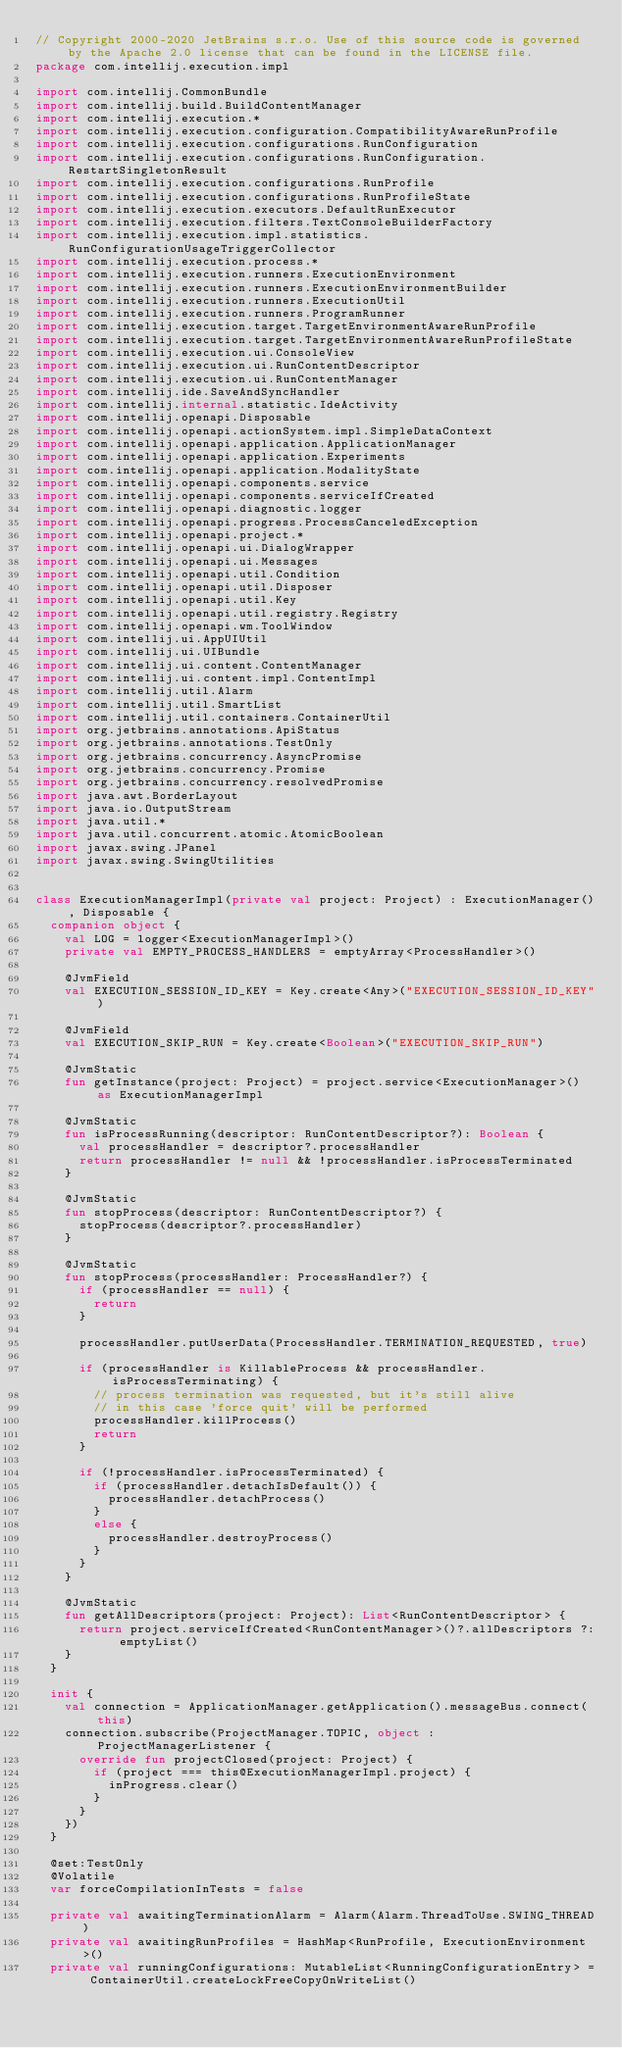<code> <loc_0><loc_0><loc_500><loc_500><_Kotlin_>// Copyright 2000-2020 JetBrains s.r.o. Use of this source code is governed by the Apache 2.0 license that can be found in the LICENSE file.
package com.intellij.execution.impl

import com.intellij.CommonBundle
import com.intellij.build.BuildContentManager
import com.intellij.execution.*
import com.intellij.execution.configuration.CompatibilityAwareRunProfile
import com.intellij.execution.configurations.RunConfiguration
import com.intellij.execution.configurations.RunConfiguration.RestartSingletonResult
import com.intellij.execution.configurations.RunProfile
import com.intellij.execution.configurations.RunProfileState
import com.intellij.execution.executors.DefaultRunExecutor
import com.intellij.execution.filters.TextConsoleBuilderFactory
import com.intellij.execution.impl.statistics.RunConfigurationUsageTriggerCollector
import com.intellij.execution.process.*
import com.intellij.execution.runners.ExecutionEnvironment
import com.intellij.execution.runners.ExecutionEnvironmentBuilder
import com.intellij.execution.runners.ExecutionUtil
import com.intellij.execution.runners.ProgramRunner
import com.intellij.execution.target.TargetEnvironmentAwareRunProfile
import com.intellij.execution.target.TargetEnvironmentAwareRunProfileState
import com.intellij.execution.ui.ConsoleView
import com.intellij.execution.ui.RunContentDescriptor
import com.intellij.execution.ui.RunContentManager
import com.intellij.ide.SaveAndSyncHandler
import com.intellij.internal.statistic.IdeActivity
import com.intellij.openapi.Disposable
import com.intellij.openapi.actionSystem.impl.SimpleDataContext
import com.intellij.openapi.application.ApplicationManager
import com.intellij.openapi.application.Experiments
import com.intellij.openapi.application.ModalityState
import com.intellij.openapi.components.service
import com.intellij.openapi.components.serviceIfCreated
import com.intellij.openapi.diagnostic.logger
import com.intellij.openapi.progress.ProcessCanceledException
import com.intellij.openapi.project.*
import com.intellij.openapi.ui.DialogWrapper
import com.intellij.openapi.ui.Messages
import com.intellij.openapi.util.Condition
import com.intellij.openapi.util.Disposer
import com.intellij.openapi.util.Key
import com.intellij.openapi.util.registry.Registry
import com.intellij.openapi.wm.ToolWindow
import com.intellij.ui.AppUIUtil
import com.intellij.ui.UIBundle
import com.intellij.ui.content.ContentManager
import com.intellij.ui.content.impl.ContentImpl
import com.intellij.util.Alarm
import com.intellij.util.SmartList
import com.intellij.util.containers.ContainerUtil
import org.jetbrains.annotations.ApiStatus
import org.jetbrains.annotations.TestOnly
import org.jetbrains.concurrency.AsyncPromise
import org.jetbrains.concurrency.Promise
import org.jetbrains.concurrency.resolvedPromise
import java.awt.BorderLayout
import java.io.OutputStream
import java.util.*
import java.util.concurrent.atomic.AtomicBoolean
import javax.swing.JPanel
import javax.swing.SwingUtilities


class ExecutionManagerImpl(private val project: Project) : ExecutionManager(), Disposable {
  companion object {
    val LOG = logger<ExecutionManagerImpl>()
    private val EMPTY_PROCESS_HANDLERS = emptyArray<ProcessHandler>()

    @JvmField
    val EXECUTION_SESSION_ID_KEY = Key.create<Any>("EXECUTION_SESSION_ID_KEY")

    @JvmField
    val EXECUTION_SKIP_RUN = Key.create<Boolean>("EXECUTION_SKIP_RUN")

    @JvmStatic
    fun getInstance(project: Project) = project.service<ExecutionManager>() as ExecutionManagerImpl

    @JvmStatic
    fun isProcessRunning(descriptor: RunContentDescriptor?): Boolean {
      val processHandler = descriptor?.processHandler
      return processHandler != null && !processHandler.isProcessTerminated
    }

    @JvmStatic
    fun stopProcess(descriptor: RunContentDescriptor?) {
      stopProcess(descriptor?.processHandler)
    }

    @JvmStatic
    fun stopProcess(processHandler: ProcessHandler?) {
      if (processHandler == null) {
        return
      }

      processHandler.putUserData(ProcessHandler.TERMINATION_REQUESTED, true)

      if (processHandler is KillableProcess && processHandler.isProcessTerminating) {
        // process termination was requested, but it's still alive
        // in this case 'force quit' will be performed
        processHandler.killProcess()
        return
      }

      if (!processHandler.isProcessTerminated) {
        if (processHandler.detachIsDefault()) {
          processHandler.detachProcess()
        }
        else {
          processHandler.destroyProcess()
        }
      }
    }

    @JvmStatic
    fun getAllDescriptors(project: Project): List<RunContentDescriptor> {
      return project.serviceIfCreated<RunContentManager>()?.allDescriptors ?: emptyList()
    }
  }

  init {
    val connection = ApplicationManager.getApplication().messageBus.connect(this)
    connection.subscribe(ProjectManager.TOPIC, object : ProjectManagerListener {
      override fun projectClosed(project: Project) {
        if (project === this@ExecutionManagerImpl.project) {
          inProgress.clear()
        }
      }
    })
  }

  @set:TestOnly
  @Volatile
  var forceCompilationInTests = false

  private val awaitingTerminationAlarm = Alarm(Alarm.ThreadToUse.SWING_THREAD)
  private val awaitingRunProfiles = HashMap<RunProfile, ExecutionEnvironment>()
  private val runningConfigurations: MutableList<RunningConfigurationEntry> = ContainerUtil.createLockFreeCopyOnWriteList()
</code> 